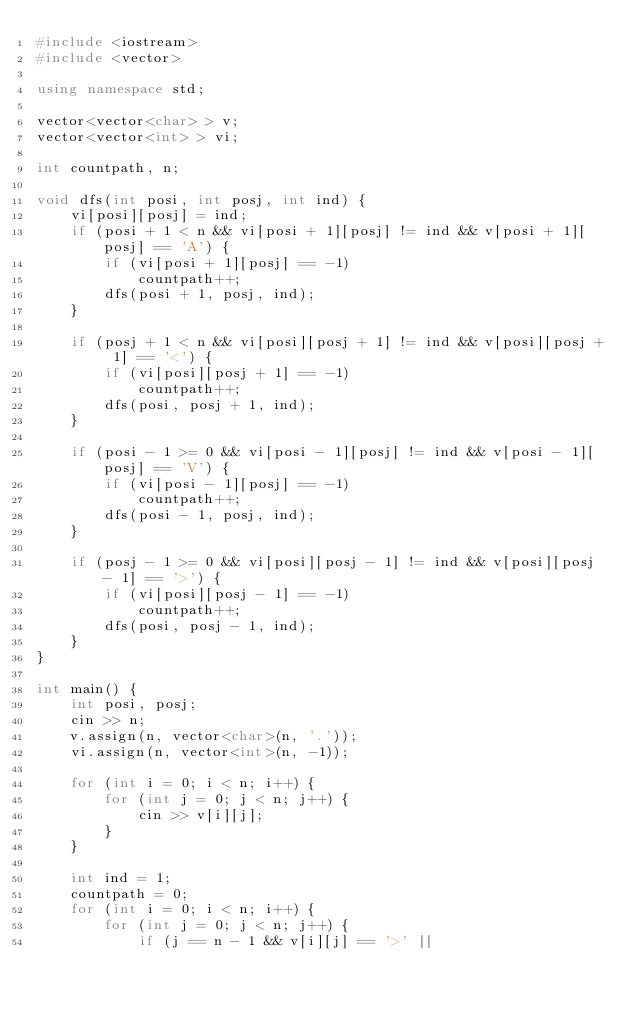Convert code to text. <code><loc_0><loc_0><loc_500><loc_500><_C++_>#include <iostream>
#include <vector>

using namespace std;

vector<vector<char> > v;
vector<vector<int> > vi;

int countpath, n;

void dfs(int posi, int posj, int ind) {
    vi[posi][posj] = ind;
    if (posi + 1 < n && vi[posi + 1][posj] != ind && v[posi + 1][posj] == 'A') {
        if (vi[posi + 1][posj] == -1)
            countpath++;
        dfs(posi + 1, posj, ind);
    }

    if (posj + 1 < n && vi[posi][posj + 1] != ind && v[posi][posj + 1] == '<') {
        if (vi[posi][posj + 1] == -1)
            countpath++;
        dfs(posi, posj + 1, ind);
    }

    if (posi - 1 >= 0 && vi[posi - 1][posj] != ind && v[posi - 1][posj] == 'V') {
        if (vi[posi - 1][posj] == -1)
            countpath++;
        dfs(posi - 1, posj, ind);
    }

    if (posj - 1 >= 0 && vi[posi][posj - 1] != ind && v[posi][posj - 1] == '>') {
        if (vi[posi][posj - 1] == -1)
            countpath++;
        dfs(posi, posj - 1, ind);
    }
}

int main() {
    int posi, posj;
    cin >> n;
    v.assign(n, vector<char>(n, '.'));
    vi.assign(n, vector<int>(n, -1));

    for (int i = 0; i < n; i++) {
        for (int j = 0; j < n; j++) {
            cin >> v[i][j];
        }
    }

    int ind = 1;
    countpath = 0;
    for (int i = 0; i < n; i++) {
        for (int j = 0; j < n; j++) {
            if (j == n - 1 && v[i][j] == '>' ||</code> 